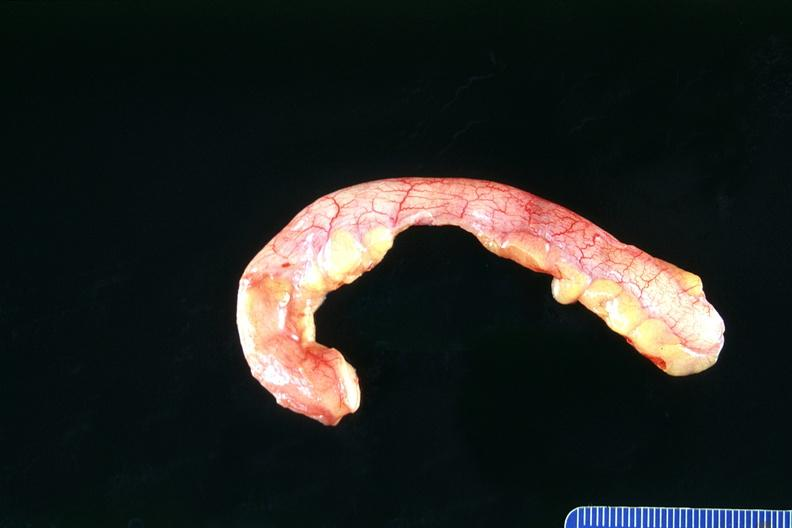s nodular tumor present?
Answer the question using a single word or phrase. No 